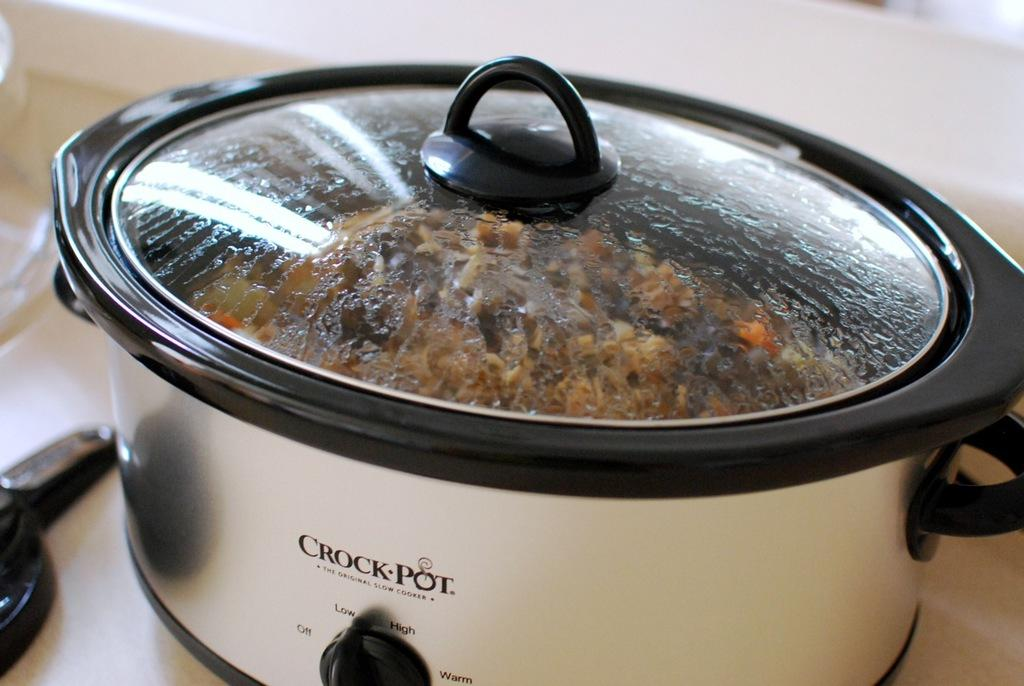<image>
Share a concise interpretation of the image provided. a working crock pot with the CROCK POT name on the front. 